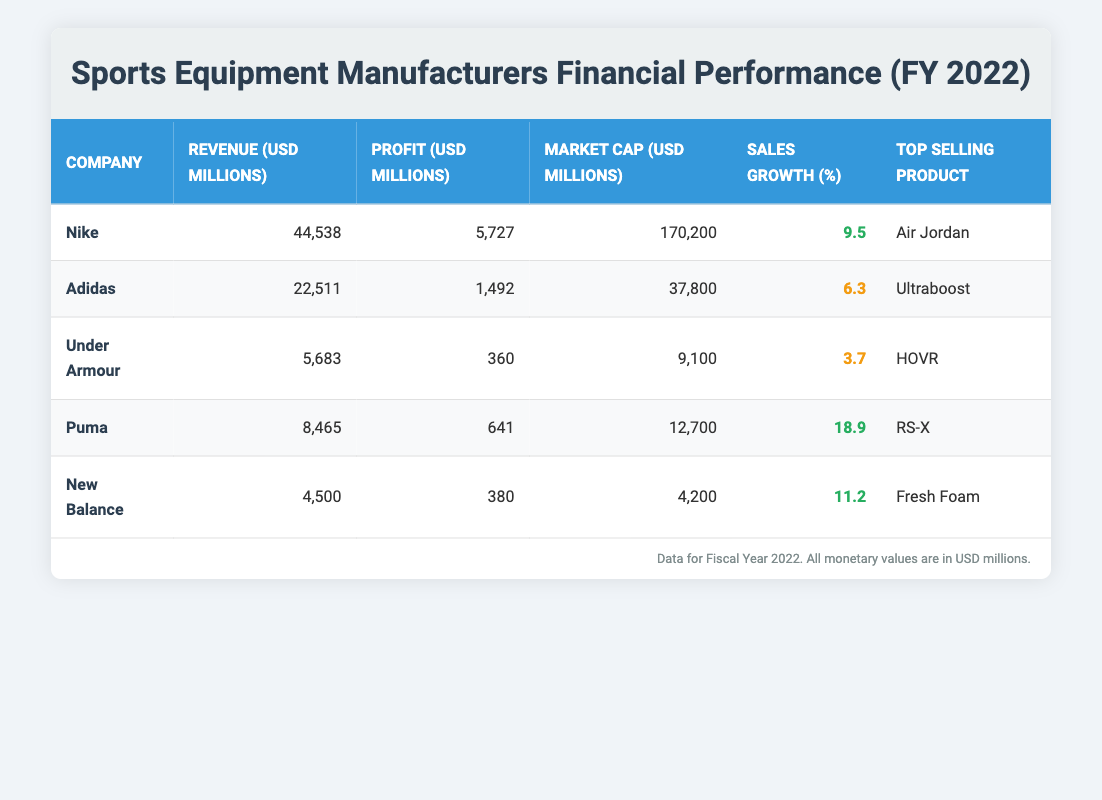What is the revenue of Nike? The revenue for Nike is clearly listed in the table as 44,538 million USD.
Answer: 44,538 million USD Which company has the highest profit? By comparing the profit values of each company in the table, Nike has the highest profit at 5,727 million USD.
Answer: Nike What is the sales growth percentage of Adidas? The sales growth percentage for Adidas is directly mentioned in the table as 6.3 percent.
Answer: 6.3 percent What are the total revenues of Puma and Under Armour combined? The revenue for Puma is 8,465 million USD and for Under Armour, it is 5,683 million USD. Adding these gives us a total revenue of (8,465 + 5,683) = 14,148 million USD.
Answer: 14,148 million USD Is New Balance's market capitalization greater than that of Under Armour? The market cap for New Balance is 4,200 million USD, while Under Armour's is 9,100 million USD. Since 4,200 is less than 9,100, New Balance's market capitalization is not greater.
Answer: No What is the average sales growth of the companies listed in the table? The sales growth percentages are 9.5, 6.3, 3.7, 18.9, and 11.2. Adding them gives 49.6, and dividing by the number of companies (5) results in an average sales growth of 49.6 / 5 = 9.92 percent.
Answer: 9.92 percent Which company had the lowest sales growth? Comparing the sales growth figures, Under Armour has the lowest sales growth at 3.7 percent when looking at all the values in the table.
Answer: Under Armour What is the market cap difference between Nike and Adidas? The market cap for Nike is 170,200 million USD and for Adidas, it is 37,800 million USD. The difference is therefore (170,200 - 37,800) = 132,400 million USD.
Answer: 132,400 million USD Did any company have a profit of less than 500 million USD? Comparing the profit figures, Under Armour's profit is 360 million USD, which is less than 500 million. Therefore, the answer is yes, there is one company that had a profit of less than 500 million USD.
Answer: Yes 